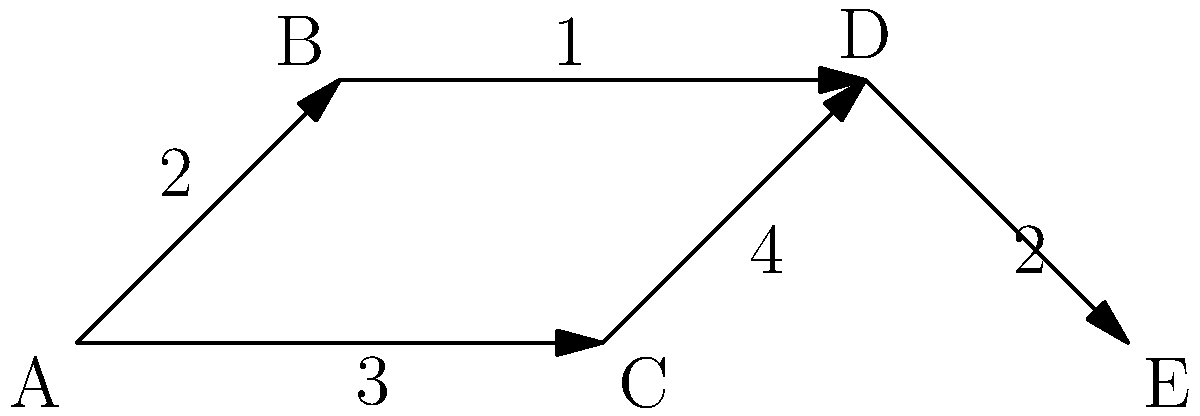In this communication network, nodes represent different channels (e.g., blogs, social media, press releases), and edge weights represent the time (in hours) for information to flow between channels. What is the minimum time required for information to reach channel E from channel A? To find the minimum time for information to reach channel E from channel A, we need to identify the shortest path from A to E. Let's analyze the possible paths:

1. Path A -> B -> D -> E:
   Time = 2 + 1 + 2 = 5 hours

2. Path A -> C -> D -> E:
   Time = 3 + 4 + 2 = 9 hours

3. There are no other possible paths from A to E.

Comparing the two paths:
- Path 1 (A -> B -> D -> E) takes 5 hours
- Path 2 (A -> C -> D -> E) takes 9 hours

Therefore, the minimum time required for information to reach channel E from channel A is 5 hours, following the path A -> B -> D -> E.

This optimization demonstrates the importance of choosing the most efficient communication channels and understanding the flow of information in a PR network. As a PR professional using blogs for industry information, this network analysis can help in planning the dissemination of key messages or responding to time-sensitive issues.
Answer: 5 hours 